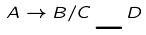Convert formula to latex. <formula><loc_0><loc_0><loc_500><loc_500>A \rightarrow B / C \_ D</formula> 